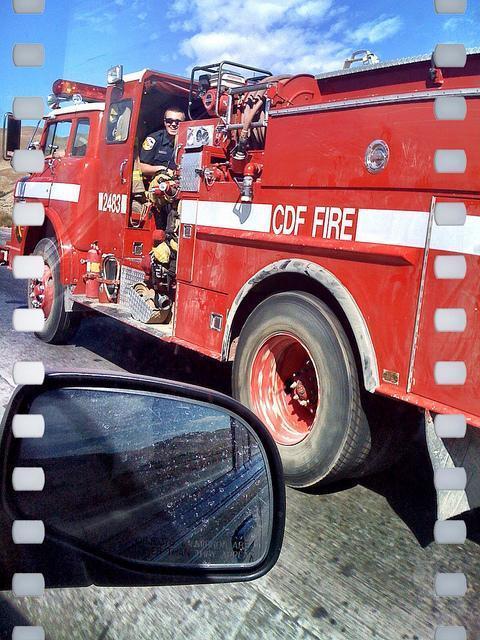How many brown cows are there?
Give a very brief answer. 0. 